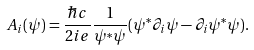Convert formula to latex. <formula><loc_0><loc_0><loc_500><loc_500>A _ { i } ( \psi ) = \frac { \hbar { c } } { 2 i e } \frac { 1 } { \psi ^ { \ast } \psi } ( \psi ^ { \ast } \partial _ { i } \psi - \partial _ { i } \psi ^ { \ast } \psi ) .</formula> 